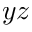<formula> <loc_0><loc_0><loc_500><loc_500>y z</formula> 